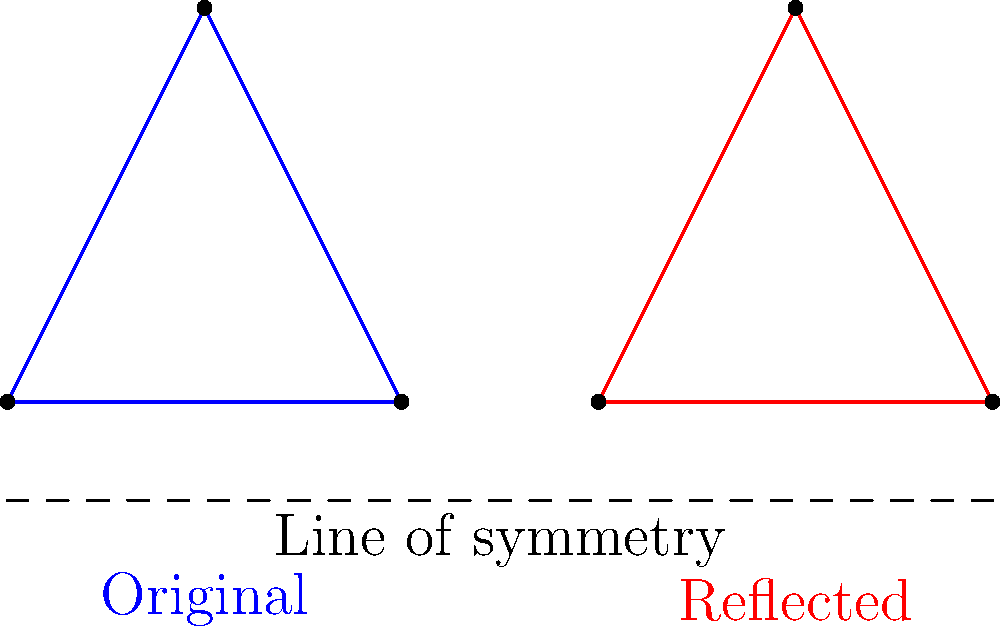Consider the famous "Flying Wedge" battle formation, represented by the blue triangle ABC in the diagram. If this formation is reflected across the dashed line of symmetry, resulting in the red triangle DEF, how does this transformation affect the strategic advantages of the formation? Specifically, how does the orientation of the formation change, and what implications might this have for its effectiveness in different battlefield scenarios? To analyze the effect of the reflection on the "Flying Wedge" formation, let's follow these steps:

1. Observe the original formation (blue triangle ABC):
   - Point C is the lead point of the wedge.
   - Points A and B form the base of the formation.

2. Examine the reflected formation (red triangle DEF):
   - Point F is now the lead point of the wedge.
   - Points D and E form the new base of the formation.

3. Compare the orientations:
   - The original formation faces upward and to the right.
   - The reflected formation faces upward and to the left.

4. Analyze the strategic implications:
   a) Direction of attack: 
      - The original formation is suited for attacks moving right.
      - The reflected formation is better for attacks moving left.

   b) Defensive positioning:
      - The original formation presents its strongest point (C) to threats from the upper-right.
      - The reflected formation is strongest against threats from the upper-left.

   c) Flanking considerations:
      - The original formation's right flank (BC) is more exposed.
      - The reflected formation's left flank (DF) is more vulnerable.

   d) Terrain adaptation:
      - The reflection allows the formation to be quickly adapted to different battlefield terrains or enemy positions without changing its inherent structure.

5. Historical context:
   - This transformation demonstrates how commanders could quickly adapt formations to changing battlefield conditions, maintaining the formation's strength while altering its orientation.

6. Tactical flexibility:
   - The ability to "reflect" a formation provides commanders with increased tactical options without requiring troops to learn new formations.
Answer: The reflection reverses the formation's orientation, changing its direction of attack, defensive strengths, and vulnerabilities, thus providing tactical flexibility for different battlefield scenarios. 